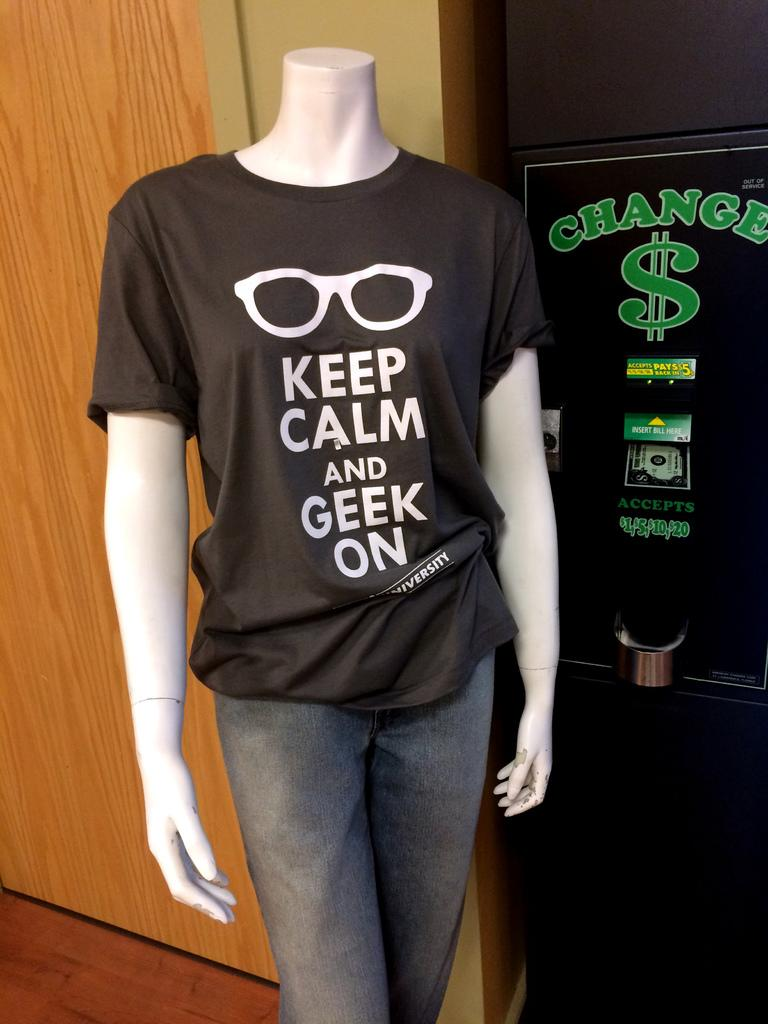Provide a one-sentence caption for the provided image. A manikin wearing a black shirt with sunglasses on it saying "Keep Calm and Geek on" also wearing gray sweat pant standing in front a change machine. 